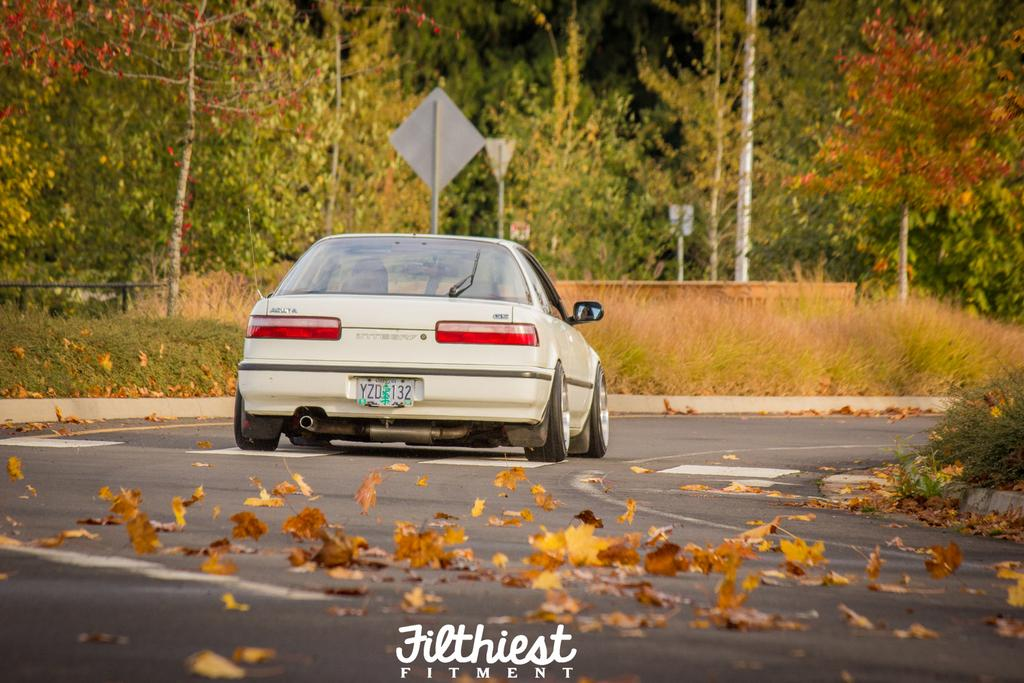What is the main subject of the image? There is a vehicle in the image. What can be seen on the road in the image? Dried leaves are present on the road. What type of vegetation is visible on both sides of the road? Grass is visible on both sides of the road. What is visible in the background of the image? There are boards and many trees in the background of the image. What type of operation is being performed on the cushion in the image? There is no cushion present in the image, so no operation can be performed on it. 